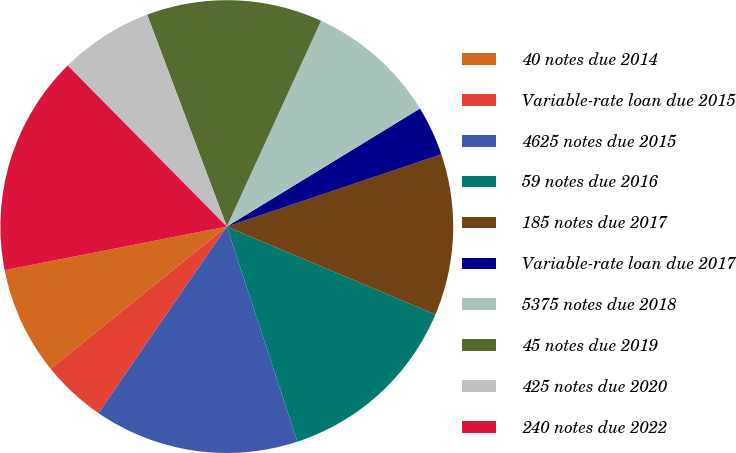Convert chart to OTSL. <chart><loc_0><loc_0><loc_500><loc_500><pie_chart><fcel>40 notes due 2014<fcel>Variable-rate loan due 2015<fcel>4625 notes due 2015<fcel>59 notes due 2016<fcel>185 notes due 2017<fcel>Variable-rate loan due 2017<fcel>5375 notes due 2018<fcel>45 notes due 2019<fcel>425 notes due 2020<fcel>240 notes due 2022<nl><fcel>7.72%<fcel>4.6%<fcel>14.64%<fcel>13.6%<fcel>11.52%<fcel>3.56%<fcel>9.43%<fcel>12.56%<fcel>6.68%<fcel>15.68%<nl></chart> 